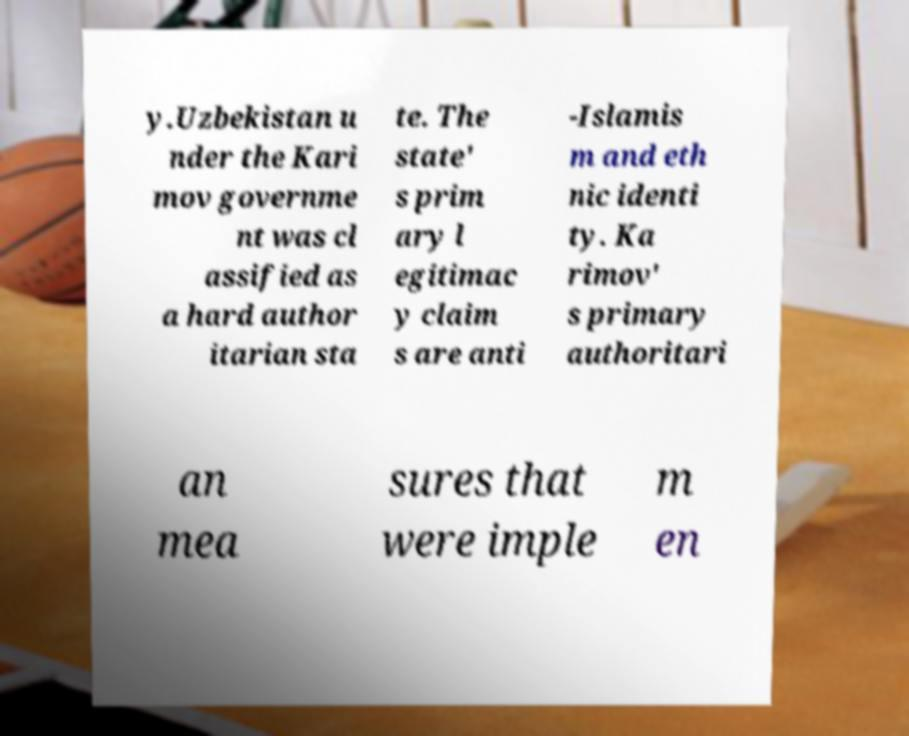Could you extract and type out the text from this image? y.Uzbekistan u nder the Kari mov governme nt was cl assified as a hard author itarian sta te. The state' s prim ary l egitimac y claim s are anti -Islamis m and eth nic identi ty. Ka rimov' s primary authoritari an mea sures that were imple m en 